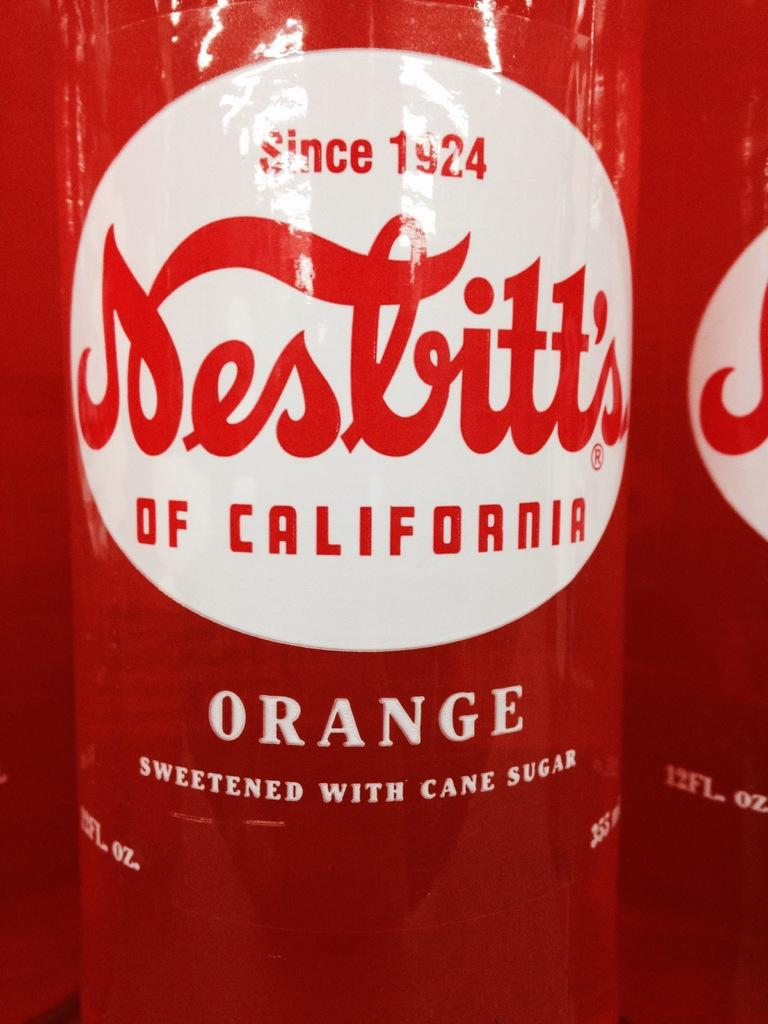<image>
Relay a brief, clear account of the picture shown. A bottle of orange soda sweetened with cane sugar has a white label. 